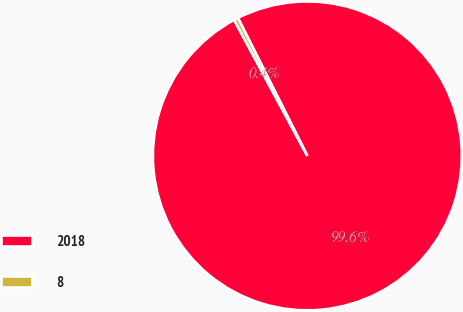<chart> <loc_0><loc_0><loc_500><loc_500><pie_chart><fcel>2018<fcel>8<nl><fcel>99.56%<fcel>0.44%<nl></chart> 